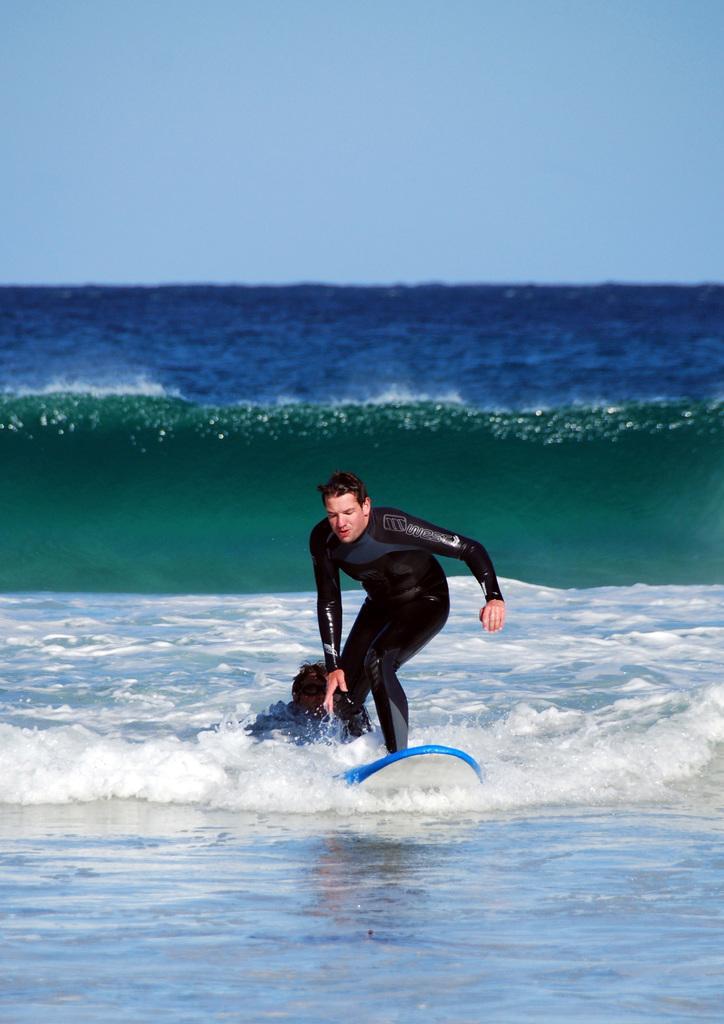In one or two sentences, can you explain what this image depicts? The man in black T-shirt is surfing on the water. In the background, we see water and this water might be in the sea or in the ocean. 